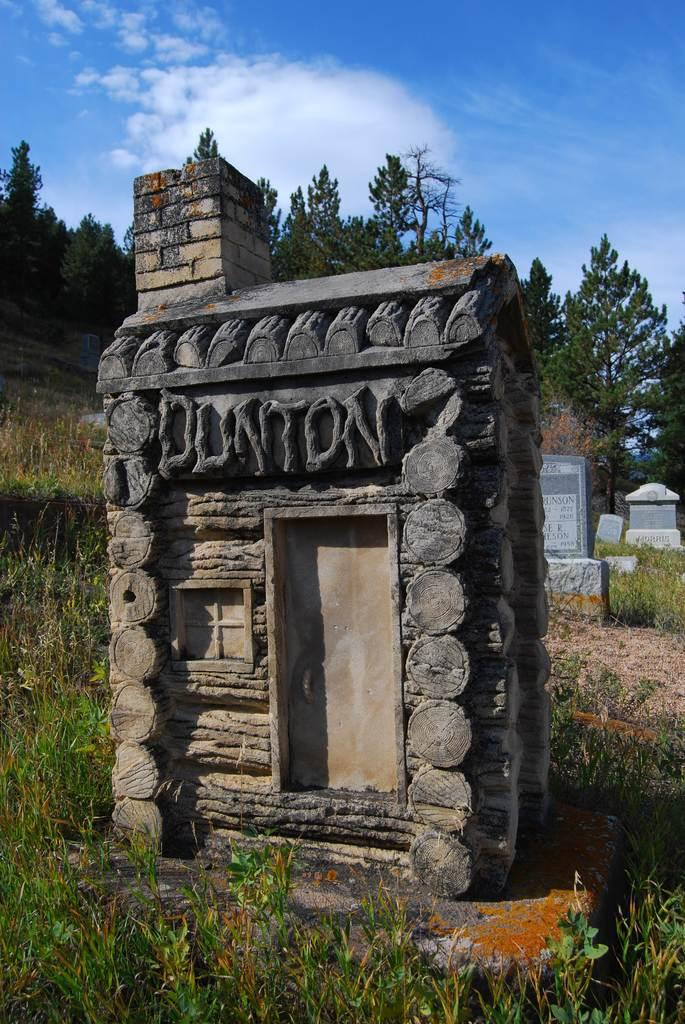<image>
Share a concise interpretation of the image provided. a small little building with letters carved into it that make the word 'Dunton' 